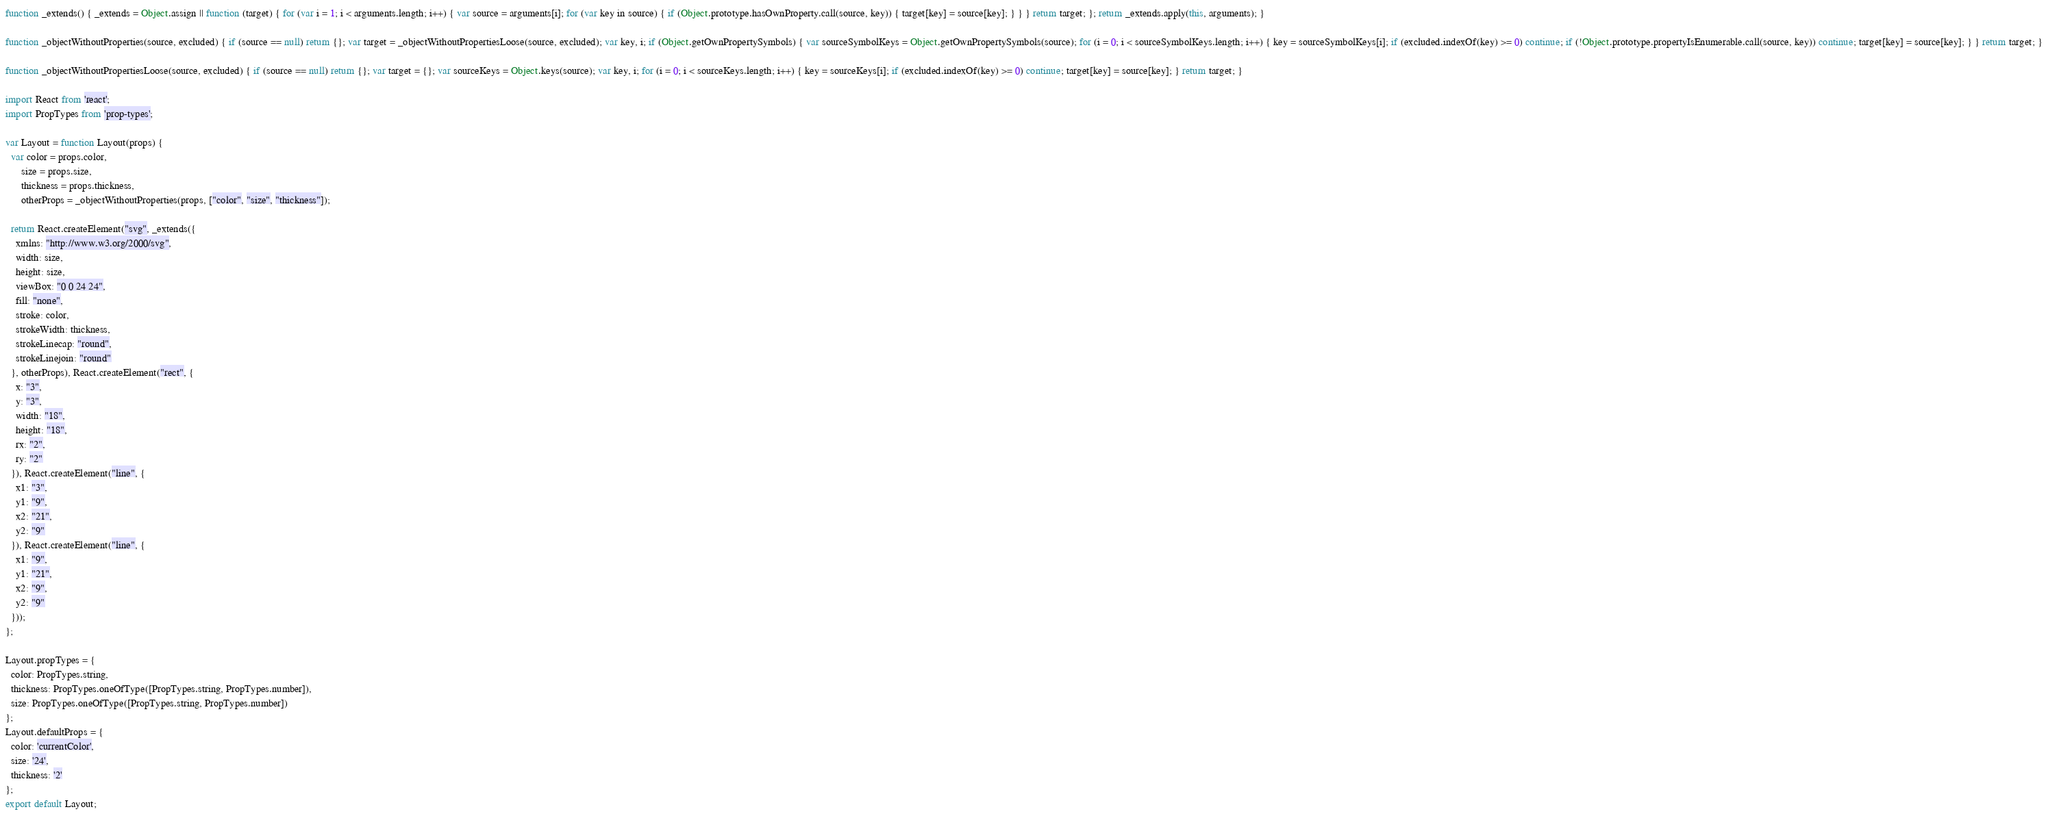Convert code to text. <code><loc_0><loc_0><loc_500><loc_500><_JavaScript_>function _extends() { _extends = Object.assign || function (target) { for (var i = 1; i < arguments.length; i++) { var source = arguments[i]; for (var key in source) { if (Object.prototype.hasOwnProperty.call(source, key)) { target[key] = source[key]; } } } return target; }; return _extends.apply(this, arguments); }

function _objectWithoutProperties(source, excluded) { if (source == null) return {}; var target = _objectWithoutPropertiesLoose(source, excluded); var key, i; if (Object.getOwnPropertySymbols) { var sourceSymbolKeys = Object.getOwnPropertySymbols(source); for (i = 0; i < sourceSymbolKeys.length; i++) { key = sourceSymbolKeys[i]; if (excluded.indexOf(key) >= 0) continue; if (!Object.prototype.propertyIsEnumerable.call(source, key)) continue; target[key] = source[key]; } } return target; }

function _objectWithoutPropertiesLoose(source, excluded) { if (source == null) return {}; var target = {}; var sourceKeys = Object.keys(source); var key, i; for (i = 0; i < sourceKeys.length; i++) { key = sourceKeys[i]; if (excluded.indexOf(key) >= 0) continue; target[key] = source[key]; } return target; }

import React from 'react';
import PropTypes from 'prop-types';

var Layout = function Layout(props) {
  var color = props.color,
      size = props.size,
      thickness = props.thickness,
      otherProps = _objectWithoutProperties(props, ["color", "size", "thickness"]);

  return React.createElement("svg", _extends({
    xmlns: "http://www.w3.org/2000/svg",
    width: size,
    height: size,
    viewBox: "0 0 24 24",
    fill: "none",
    stroke: color,
    strokeWidth: thickness,
    strokeLinecap: "round",
    strokeLinejoin: "round"
  }, otherProps), React.createElement("rect", {
    x: "3",
    y: "3",
    width: "18",
    height: "18",
    rx: "2",
    ry: "2"
  }), React.createElement("line", {
    x1: "3",
    y1: "9",
    x2: "21",
    y2: "9"
  }), React.createElement("line", {
    x1: "9",
    y1: "21",
    x2: "9",
    y2: "9"
  }));
};

Layout.propTypes = {
  color: PropTypes.string,
  thickness: PropTypes.oneOfType([PropTypes.string, PropTypes.number]),
  size: PropTypes.oneOfType([PropTypes.string, PropTypes.number])
};
Layout.defaultProps = {
  color: 'currentColor',
  size: '24',
  thickness: '2'
};
export default Layout;</code> 